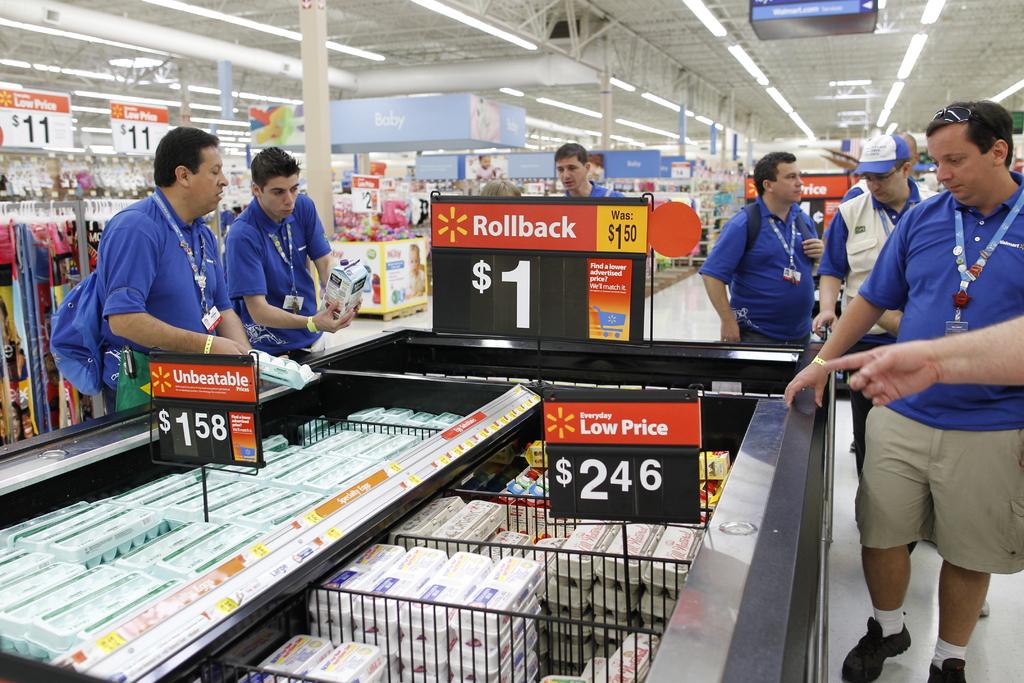Are these for a dollar?
Keep it short and to the point. Yes. What was the price?
Offer a terse response. 1.50. 